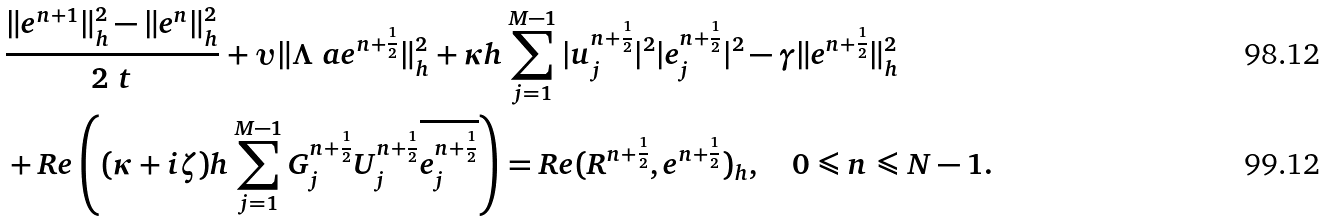Convert formula to latex. <formula><loc_0><loc_0><loc_500><loc_500>& \frac { \| e ^ { n + 1 } \| ^ { 2 } _ { h } - \| e ^ { n } \| ^ { 2 } _ { h } } { 2 \ t } + \upsilon \| \Lambda ^ { \ } a e ^ { n + \frac { 1 } { 2 } } \| ^ { 2 } _ { h } + \kappa h \sum ^ { M - 1 } _ { j = 1 } | u ^ { n + \frac { 1 } { 2 } } _ { j } | ^ { 2 } | e ^ { n + \frac { 1 } { 2 } } _ { j } | ^ { 2 } - \gamma \| e ^ { n + \frac { 1 } { 2 } } \| ^ { 2 } _ { h } \\ & + R e \left ( ( \kappa + i \zeta ) h \sum ^ { M - 1 } _ { j = 1 } G ^ { n + \frac { 1 } { 2 } } _ { j } U ^ { n + \frac { 1 } { 2 } } _ { j } \overline { e ^ { n + \frac { 1 } { 2 } } _ { j } } \right ) = R e ( R ^ { n + \frac { 1 } { 2 } } , e ^ { n + \frac { 1 } { 2 } } ) _ { h } , \quad 0 \leqslant n \leqslant N - 1 .</formula> 